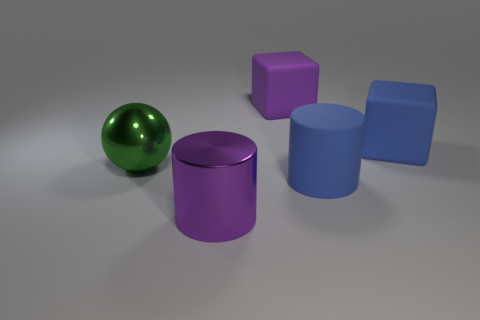Add 5 large yellow metallic cylinders. How many objects exist? 10 Subtract all cubes. How many objects are left? 3 Add 1 cylinders. How many cylinders exist? 3 Subtract 1 green spheres. How many objects are left? 4 Subtract all purple metal cylinders. Subtract all small purple objects. How many objects are left? 4 Add 1 purple shiny things. How many purple shiny things are left? 2 